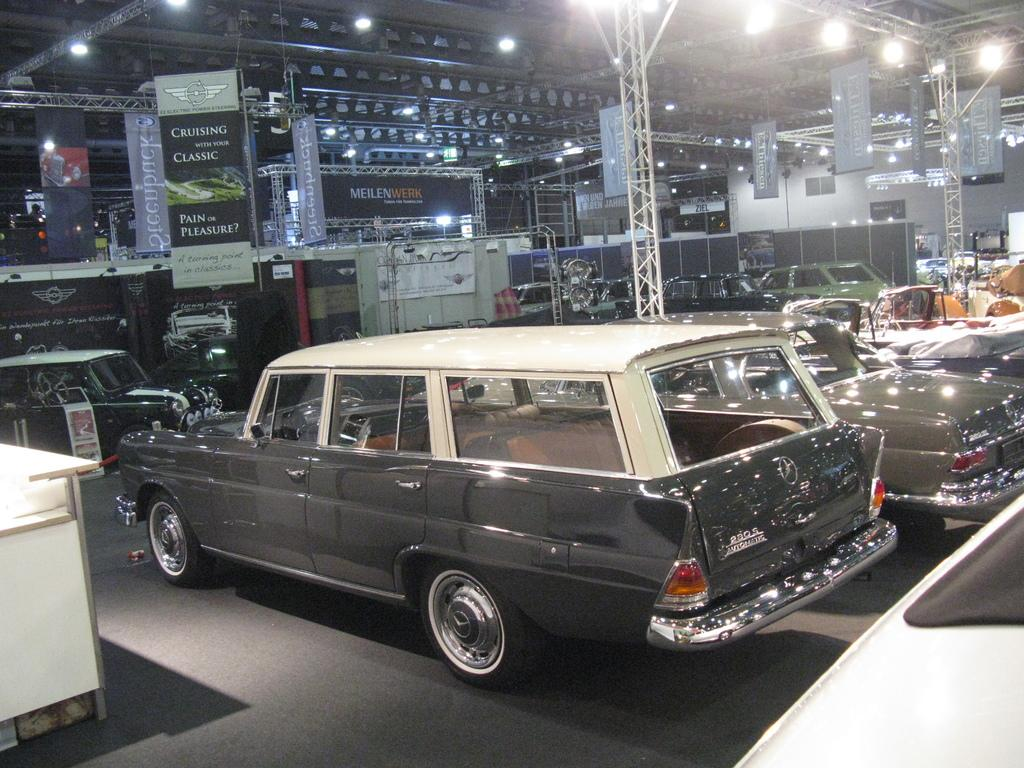What type of structures can be seen in the image? There are beams, banners, boards, and lights visible in the image. What else can be seen in the image besides the structures? There are vehicles and objects present in the image. What part of the image is visible? The floor is visible in the image. Where is the table located in the image? The table is on the left side of the image. What is the income of the person who created the list in the image? There is no list or indication of income in the image. How hot is the temperature in the image? The temperature is not mentioned or depicted in the image. 